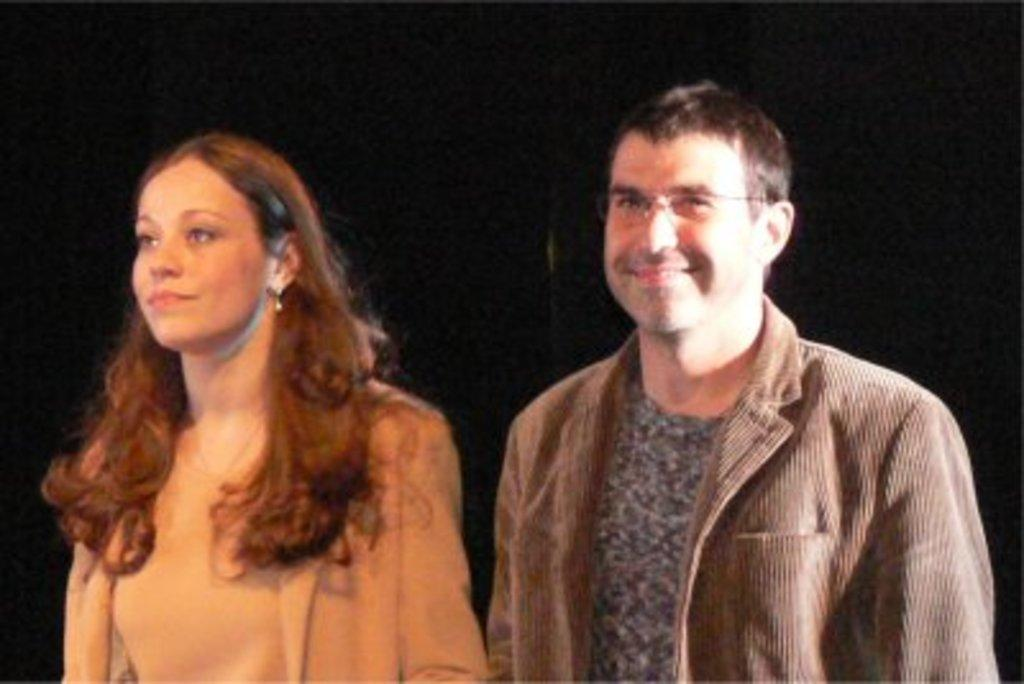Who are the people in the image? There is a woman and a man in the image. What is the man doing in the image? The man is smiling in the image. How would you describe the background of the image? The background of the image appears to be dark. How does the woman's breath affect the image? There is no mention of the woman's breath in the image, so it cannot be determined how it might affect the image. 